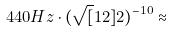Convert formula to latex. <formula><loc_0><loc_0><loc_500><loc_500>4 4 0 H z \cdot ( \sqrt { [ } 1 2 ] { 2 } ) ^ { - 1 0 } \approx</formula> 